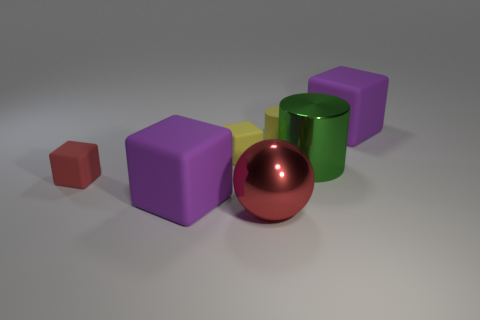How many blocks have the same color as the big sphere?
Offer a very short reply. 1. There is a cylinder that is the same material as the yellow block; what size is it?
Your answer should be compact. Small. There is a yellow block that is right of the big matte cube that is in front of the tiny cube that is in front of the small yellow matte cube; what is its size?
Ensure brevity in your answer.  Small. What is the size of the purple object in front of the small red matte thing?
Keep it short and to the point. Large. How many cyan things are small matte cylinders or cylinders?
Your answer should be very brief. 0. Is there a red metallic thing of the same size as the red block?
Provide a succinct answer. No. What is the material of the red ball that is the same size as the green metal thing?
Give a very brief answer. Metal. Do the purple rubber block that is behind the red rubber object and the shiny thing that is to the right of the big shiny sphere have the same size?
Make the answer very short. Yes. How many objects are either gray matte balls or purple rubber things in front of the yellow matte cylinder?
Offer a very short reply. 1. Is there a yellow rubber object that has the same shape as the big green thing?
Ensure brevity in your answer.  Yes. 